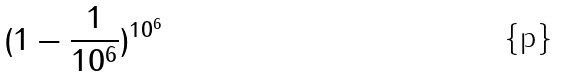<formula> <loc_0><loc_0><loc_500><loc_500>( 1 - \frac { 1 } { 1 0 ^ { 6 } } ) ^ { 1 0 ^ { 6 } }</formula> 